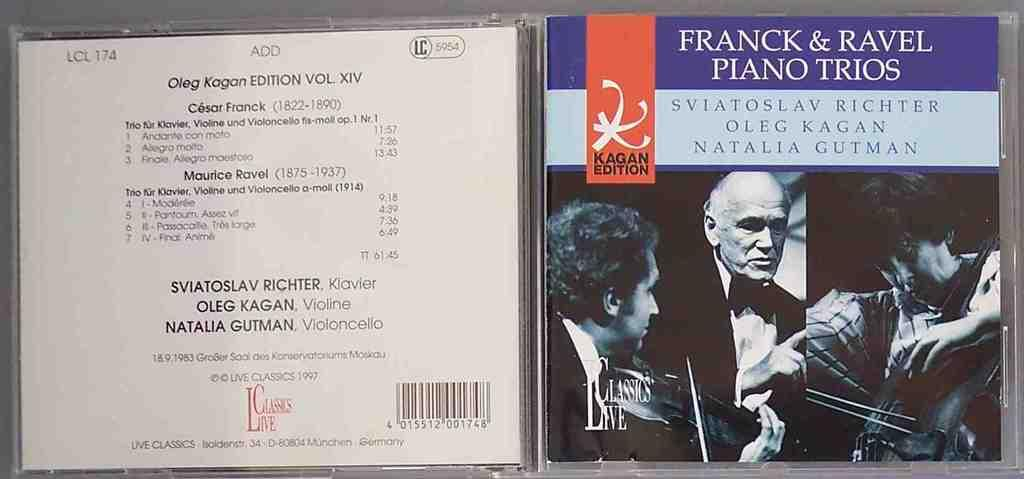<image>
Give a short and clear explanation of the subsequent image. a CD with a FRANCK & RAVEL PIANO TRIOS music n it. 